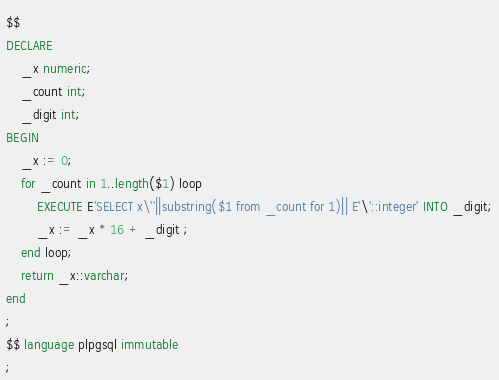<code> <loc_0><loc_0><loc_500><loc_500><_SQL_>$$
DECLARE
	_x numeric;
	_count int;
	_digit int;
BEGIN
	_x := 0;
	for _count in 1..length($1) loop
		EXECUTE E'SELECT x\''||substring($1 from _count for 1)|| E'\'::integer' INTO _digit;
		_x := _x * 16 + _digit ;
	end loop;
	return _x::varchar;
end
;
$$ language plpgsql immutable
;
</code> 